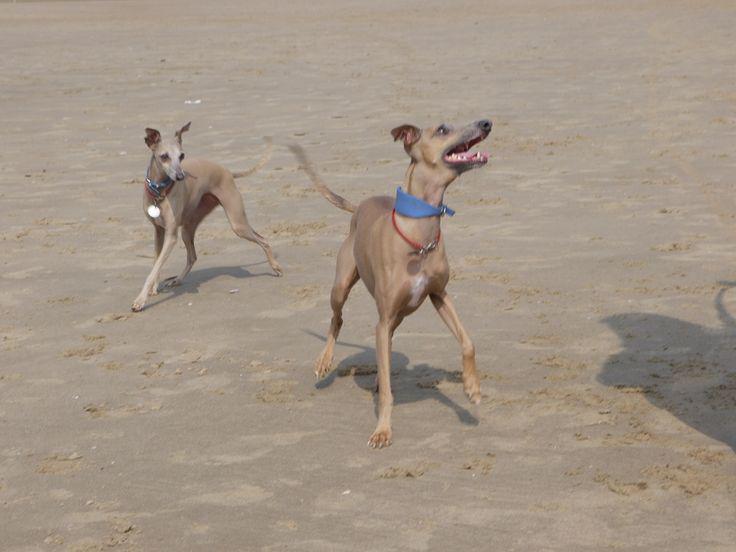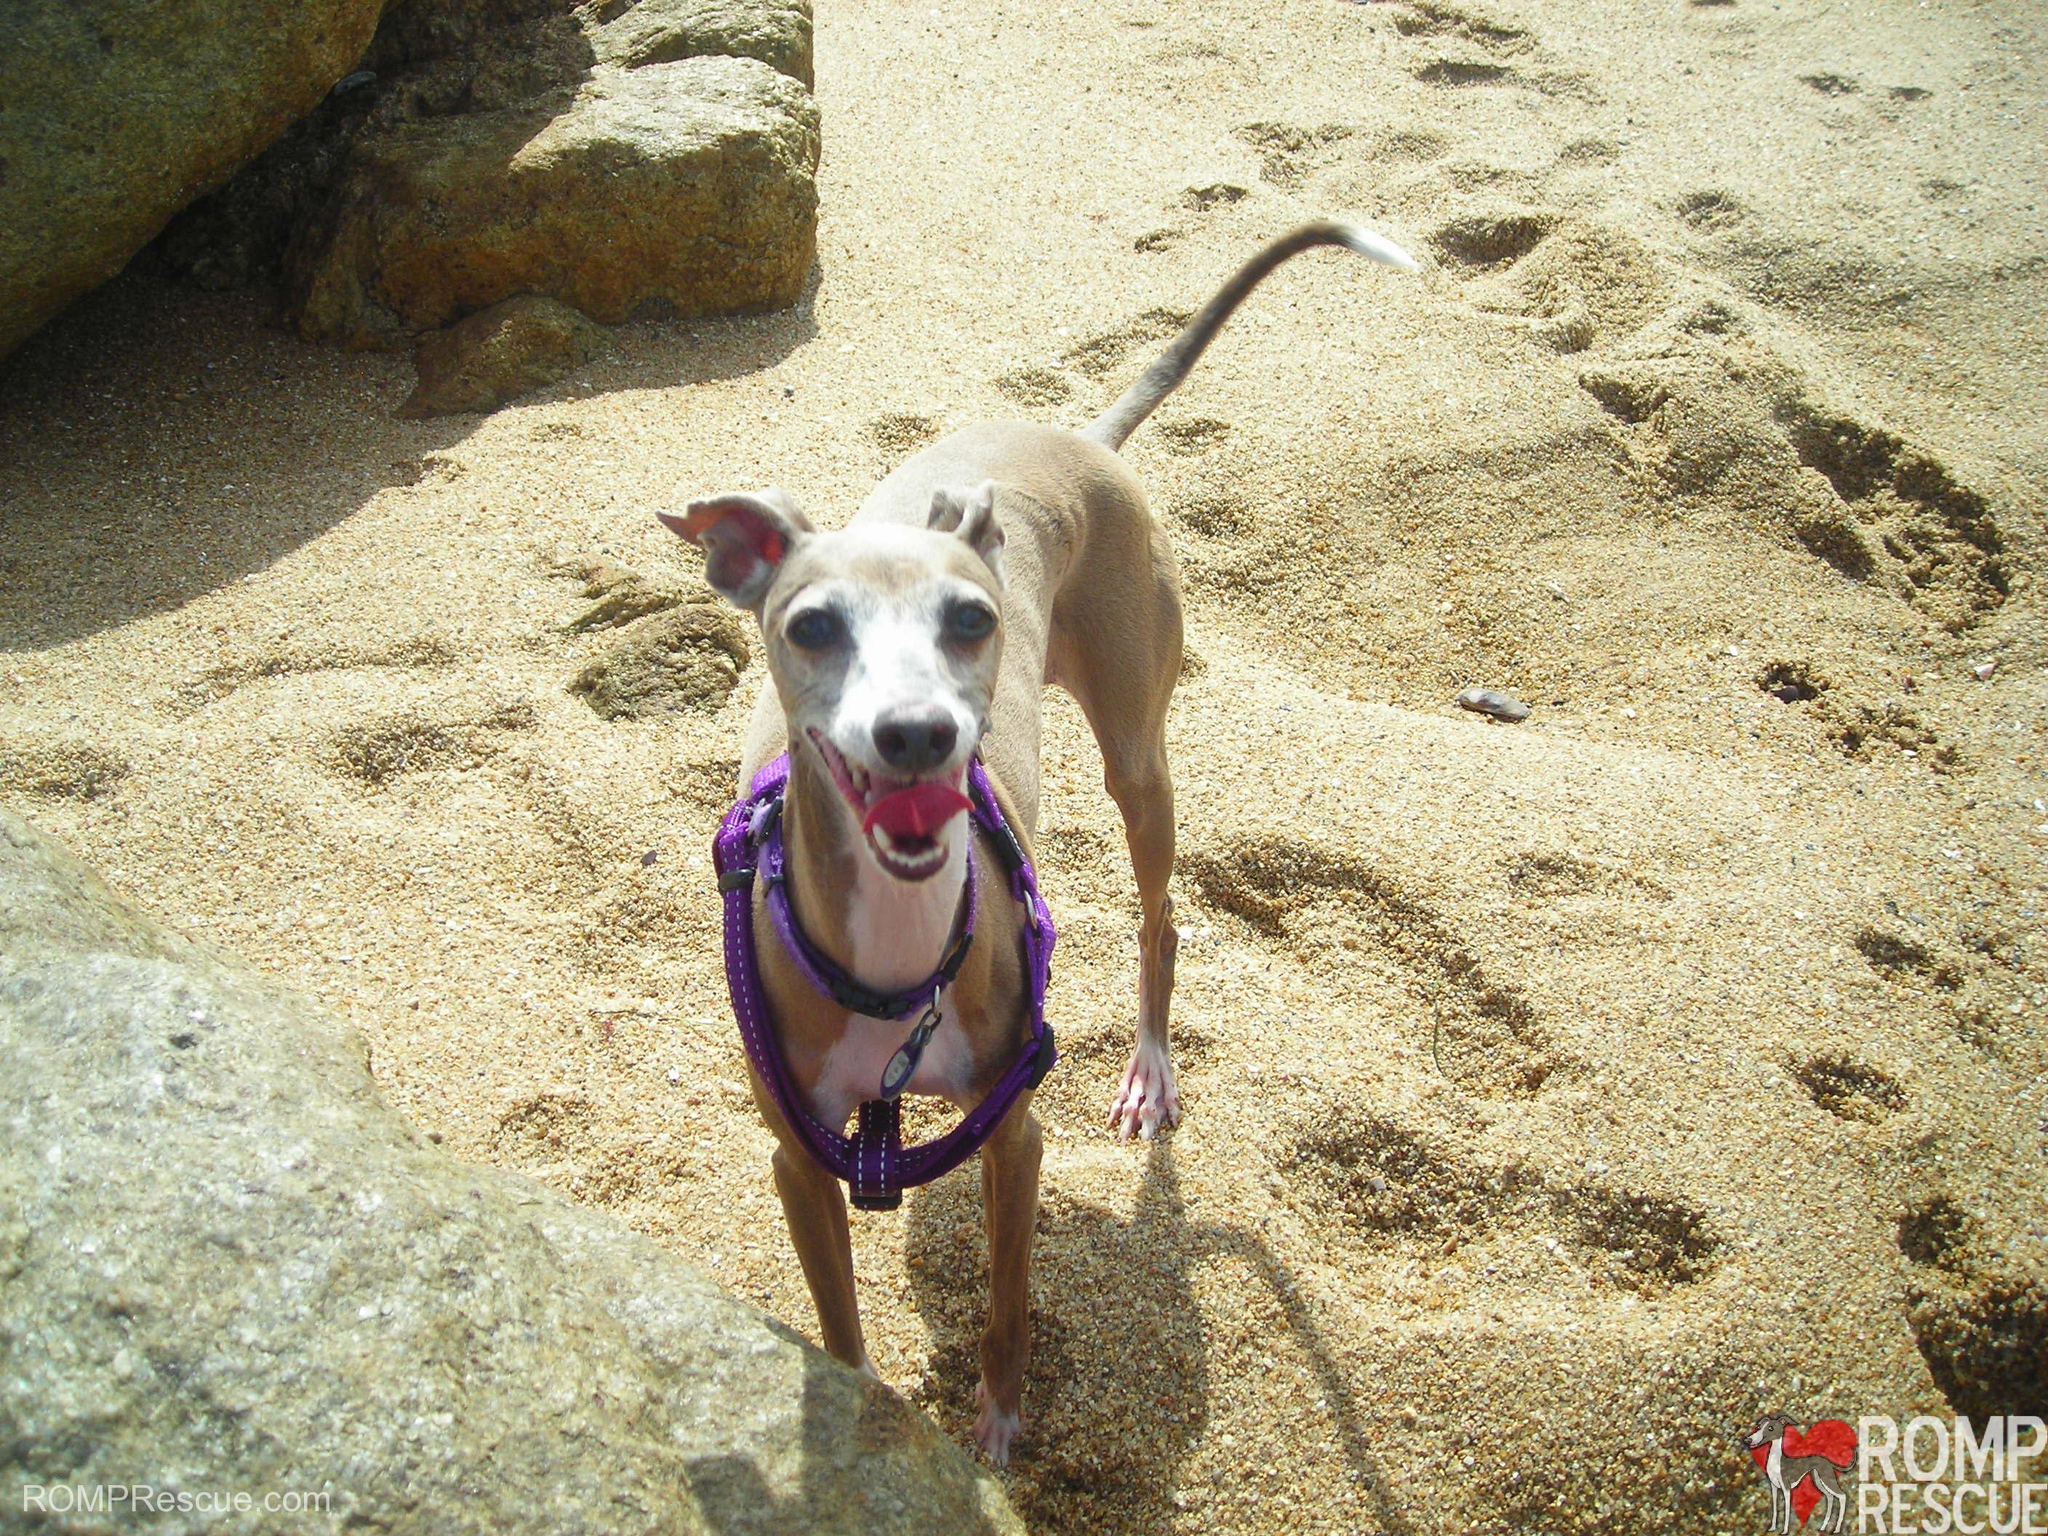The first image is the image on the left, the second image is the image on the right. Assess this claim about the two images: "Two dogs, one with an open mouth, are near one another on a sandy beach in one image.". Correct or not? Answer yes or no. Yes. The first image is the image on the left, the second image is the image on the right. Given the left and right images, does the statement "One of the two dogs in the left image has its mouth open, displaying its teeth and a bit of tongue." hold true? Answer yes or no. Yes. 